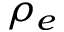Convert formula to latex. <formula><loc_0><loc_0><loc_500><loc_500>\rho _ { e }</formula> 